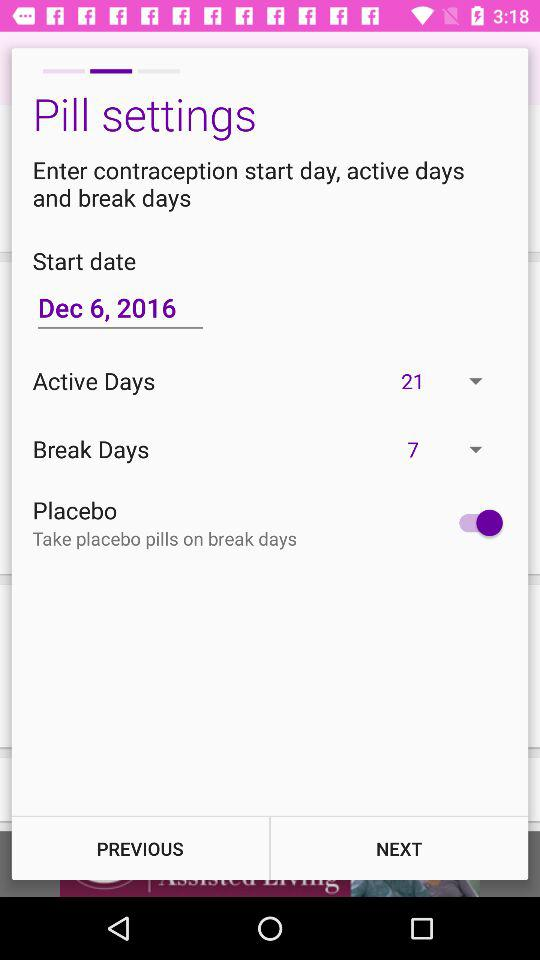What is the start date? The start date is 6th December, 2016. 